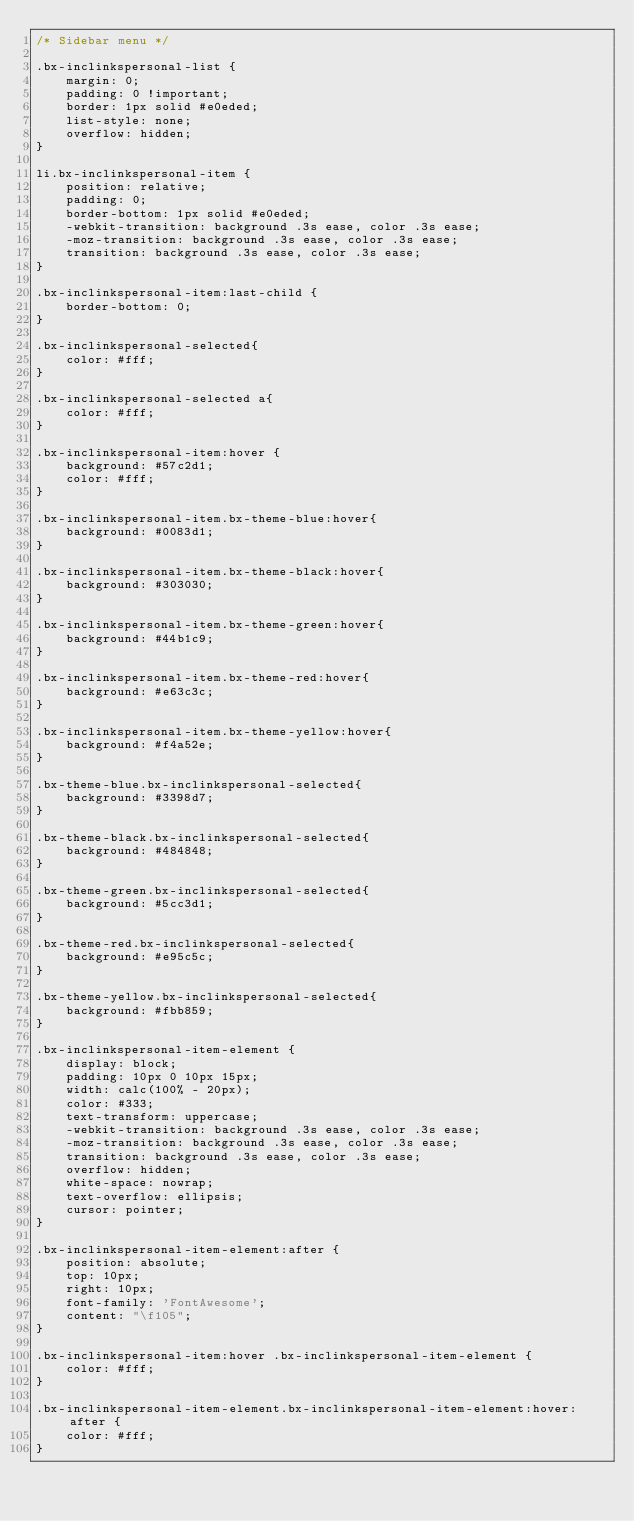<code> <loc_0><loc_0><loc_500><loc_500><_CSS_>/* Sidebar menu */

.bx-inclinkspersonal-list {
	margin: 0;
	padding: 0 !important;
	border: 1px solid #e0eded;
	list-style: none;
	overflow: hidden;
}

li.bx-inclinkspersonal-item {
	position: relative;
	padding: 0;
	border-bottom: 1px solid #e0eded;
	-webkit-transition: background .3s ease, color .3s ease;
	-moz-transition: background .3s ease, color .3s ease;
	transition: background .3s ease, color .3s ease;
}

.bx-inclinkspersonal-item:last-child {
	border-bottom: 0;
}

.bx-inclinkspersonal-selected{
	color: #fff;
}

.bx-inclinkspersonal-selected a{
	color: #fff;
}

.bx-inclinkspersonal-item:hover {
	background: #57c2d1;
	color: #fff;
}

.bx-inclinkspersonal-item.bx-theme-blue:hover{
	background: #0083d1;
}

.bx-inclinkspersonal-item.bx-theme-black:hover{
	background: #303030;
}

.bx-inclinkspersonal-item.bx-theme-green:hover{
	background: #44b1c9;
}

.bx-inclinkspersonal-item.bx-theme-red:hover{
	background: #e63c3c;
}

.bx-inclinkspersonal-item.bx-theme-yellow:hover{
	background: #f4a52e;
}

.bx-theme-blue.bx-inclinkspersonal-selected{
	background: #3398d7;
}

.bx-theme-black.bx-inclinkspersonal-selected{
	background: #484848;
}

.bx-theme-green.bx-inclinkspersonal-selected{
	background: #5cc3d1;
}

.bx-theme-red.bx-inclinkspersonal-selected{
	background: #e95c5c;
}

.bx-theme-yellow.bx-inclinkspersonal-selected{
	background: #fbb859;
}

.bx-inclinkspersonal-item-element {
	display: block;
	padding: 10px 0 10px 15px;
	width: calc(100% - 20px);
	color: #333;
	text-transform: uppercase;
	-webkit-transition: background .3s ease, color .3s ease;
	-moz-transition: background .3s ease, color .3s ease;
	transition: background .3s ease, color .3s ease;
	overflow: hidden;
	white-space: nowrap;
	text-overflow: ellipsis;
	cursor: pointer;
}

.bx-inclinkspersonal-item-element:after {
	position: absolute;
	top: 10px;
	right: 10px;
	font-family: 'FontAwesome';
	content: "\f105";
}

.bx-inclinkspersonal-item:hover .bx-inclinkspersonal-item-element {
	color: #fff;
}

.bx-inclinkspersonal-item-element.bx-inclinkspersonal-item-element:hover:after {
	color: #fff;
}</code> 